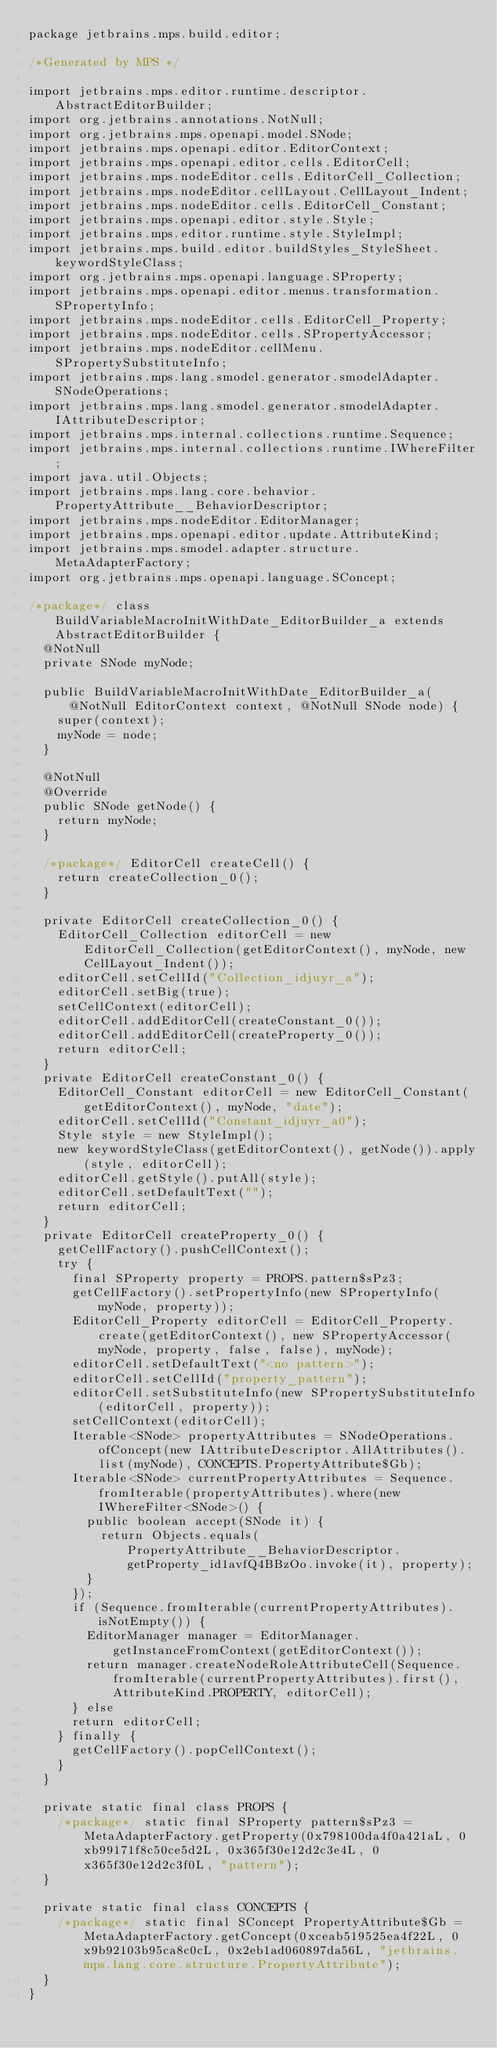<code> <loc_0><loc_0><loc_500><loc_500><_Java_>package jetbrains.mps.build.editor;

/*Generated by MPS */

import jetbrains.mps.editor.runtime.descriptor.AbstractEditorBuilder;
import org.jetbrains.annotations.NotNull;
import org.jetbrains.mps.openapi.model.SNode;
import jetbrains.mps.openapi.editor.EditorContext;
import jetbrains.mps.openapi.editor.cells.EditorCell;
import jetbrains.mps.nodeEditor.cells.EditorCell_Collection;
import jetbrains.mps.nodeEditor.cellLayout.CellLayout_Indent;
import jetbrains.mps.nodeEditor.cells.EditorCell_Constant;
import jetbrains.mps.openapi.editor.style.Style;
import jetbrains.mps.editor.runtime.style.StyleImpl;
import jetbrains.mps.build.editor.buildStyles_StyleSheet.keywordStyleClass;
import org.jetbrains.mps.openapi.language.SProperty;
import jetbrains.mps.openapi.editor.menus.transformation.SPropertyInfo;
import jetbrains.mps.nodeEditor.cells.EditorCell_Property;
import jetbrains.mps.nodeEditor.cells.SPropertyAccessor;
import jetbrains.mps.nodeEditor.cellMenu.SPropertySubstituteInfo;
import jetbrains.mps.lang.smodel.generator.smodelAdapter.SNodeOperations;
import jetbrains.mps.lang.smodel.generator.smodelAdapter.IAttributeDescriptor;
import jetbrains.mps.internal.collections.runtime.Sequence;
import jetbrains.mps.internal.collections.runtime.IWhereFilter;
import java.util.Objects;
import jetbrains.mps.lang.core.behavior.PropertyAttribute__BehaviorDescriptor;
import jetbrains.mps.nodeEditor.EditorManager;
import jetbrains.mps.openapi.editor.update.AttributeKind;
import jetbrains.mps.smodel.adapter.structure.MetaAdapterFactory;
import org.jetbrains.mps.openapi.language.SConcept;

/*package*/ class BuildVariableMacroInitWithDate_EditorBuilder_a extends AbstractEditorBuilder {
  @NotNull
  private SNode myNode;

  public BuildVariableMacroInitWithDate_EditorBuilder_a(@NotNull EditorContext context, @NotNull SNode node) {
    super(context);
    myNode = node;
  }

  @NotNull
  @Override
  public SNode getNode() {
    return myNode;
  }

  /*package*/ EditorCell createCell() {
    return createCollection_0();
  }

  private EditorCell createCollection_0() {
    EditorCell_Collection editorCell = new EditorCell_Collection(getEditorContext(), myNode, new CellLayout_Indent());
    editorCell.setCellId("Collection_idjuyr_a");
    editorCell.setBig(true);
    setCellContext(editorCell);
    editorCell.addEditorCell(createConstant_0());
    editorCell.addEditorCell(createProperty_0());
    return editorCell;
  }
  private EditorCell createConstant_0() {
    EditorCell_Constant editorCell = new EditorCell_Constant(getEditorContext(), myNode, "date");
    editorCell.setCellId("Constant_idjuyr_a0");
    Style style = new StyleImpl();
    new keywordStyleClass(getEditorContext(), getNode()).apply(style, editorCell);
    editorCell.getStyle().putAll(style);
    editorCell.setDefaultText("");
    return editorCell;
  }
  private EditorCell createProperty_0() {
    getCellFactory().pushCellContext();
    try {
      final SProperty property = PROPS.pattern$sPz3;
      getCellFactory().setPropertyInfo(new SPropertyInfo(myNode, property));
      EditorCell_Property editorCell = EditorCell_Property.create(getEditorContext(), new SPropertyAccessor(myNode, property, false, false), myNode);
      editorCell.setDefaultText("<no pattern>");
      editorCell.setCellId("property_pattern");
      editorCell.setSubstituteInfo(new SPropertySubstituteInfo(editorCell, property));
      setCellContext(editorCell);
      Iterable<SNode> propertyAttributes = SNodeOperations.ofConcept(new IAttributeDescriptor.AllAttributes().list(myNode), CONCEPTS.PropertyAttribute$Gb);
      Iterable<SNode> currentPropertyAttributes = Sequence.fromIterable(propertyAttributes).where(new IWhereFilter<SNode>() {
        public boolean accept(SNode it) {
          return Objects.equals(PropertyAttribute__BehaviorDescriptor.getProperty_id1avfQ4BBzOo.invoke(it), property);
        }
      });
      if (Sequence.fromIterable(currentPropertyAttributes).isNotEmpty()) {
        EditorManager manager = EditorManager.getInstanceFromContext(getEditorContext());
        return manager.createNodeRoleAttributeCell(Sequence.fromIterable(currentPropertyAttributes).first(), AttributeKind.PROPERTY, editorCell);
      } else
      return editorCell;
    } finally {
      getCellFactory().popCellContext();
    }
  }

  private static final class PROPS {
    /*package*/ static final SProperty pattern$sPz3 = MetaAdapterFactory.getProperty(0x798100da4f0a421aL, 0xb99171f8c50ce5d2L, 0x365f30e12d2c3e4L, 0x365f30e12d2c3f0L, "pattern");
  }

  private static final class CONCEPTS {
    /*package*/ static final SConcept PropertyAttribute$Gb = MetaAdapterFactory.getConcept(0xceab519525ea4f22L, 0x9b92103b95ca8c0cL, 0x2eb1ad060897da56L, "jetbrains.mps.lang.core.structure.PropertyAttribute");
  }
}
</code> 